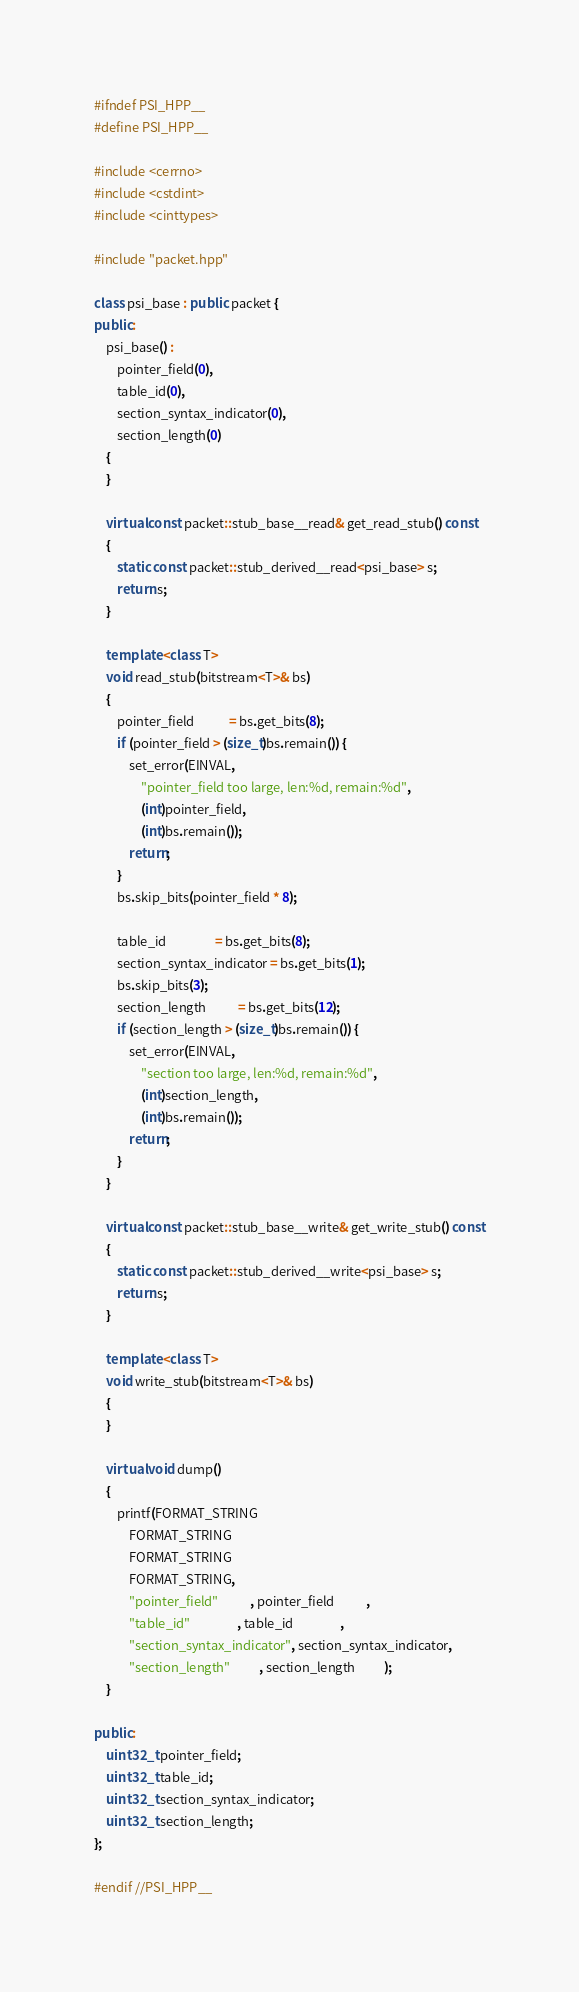Convert code to text. <code><loc_0><loc_0><loc_500><loc_500><_C++_>#ifndef PSI_HPP__
#define PSI_HPP__

#include <cerrno>
#include <cstdint>
#include <cinttypes>

#include "packet.hpp"

class psi_base : public packet {
public:
	psi_base() :
		pointer_field(0),
		table_id(0),
		section_syntax_indicator(0),
		section_length(0)
	{
	}

	virtual const packet::stub_base__read& get_read_stub() const
	{
		static const packet::stub_derived__read<psi_base> s;
		return s;
	}

	template <class T>
	void read_stub(bitstream<T>& bs)
	{
		pointer_field            = bs.get_bits(8);
		if (pointer_field > (size_t)bs.remain()) {
			set_error(EINVAL,
				"pointer_field too large, len:%d, remain:%d",
				(int)pointer_field,
				(int)bs.remain());
			return;
		}
		bs.skip_bits(pointer_field * 8);

		table_id                 = bs.get_bits(8);
		section_syntax_indicator = bs.get_bits(1);
		bs.skip_bits(3);
		section_length           = bs.get_bits(12);
		if (section_length > (size_t)bs.remain()) {
			set_error(EINVAL,
				"section too large, len:%d, remain:%d",
				(int)section_length,
				(int)bs.remain());
			return;
		}
	}

	virtual const packet::stub_base__write& get_write_stub() const
	{
		static const packet::stub_derived__write<psi_base> s;
		return s;
	}

	template <class T>
	void write_stub(bitstream<T>& bs)
	{
	}

	virtual void dump()
	{
		printf(FORMAT_STRING
			FORMAT_STRING
			FORMAT_STRING
			FORMAT_STRING,
			"pointer_field"           , pointer_field           ,
			"table_id"                , table_id                ,
			"section_syntax_indicator", section_syntax_indicator,
			"section_length"          , section_length          );
	}

public:
	uint32_t pointer_field;
	uint32_t table_id;
	uint32_t section_syntax_indicator;
	uint32_t section_length;
};

#endif //PSI_HPP__
</code> 